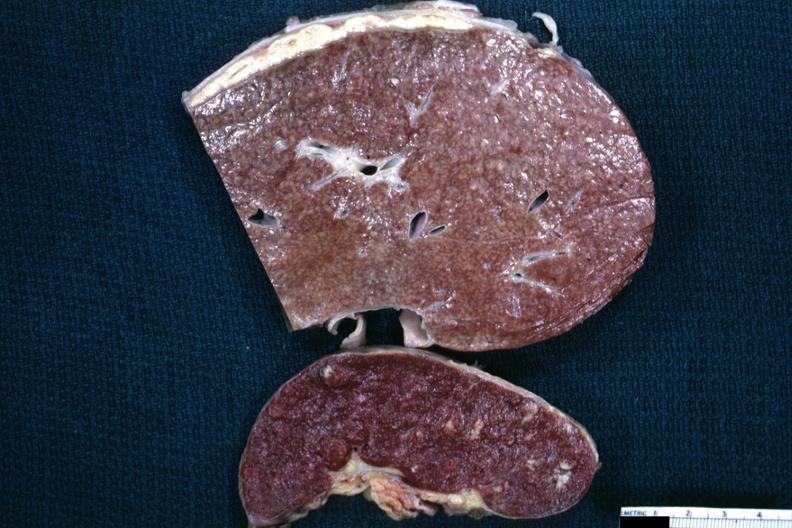what does slices of liver and spleen typical tuberculous exudate is present on capsule of liver and spleen contain?
Answer the question using a single word or phrase. Granulomata slide a close-up view the cold abscess the surface 